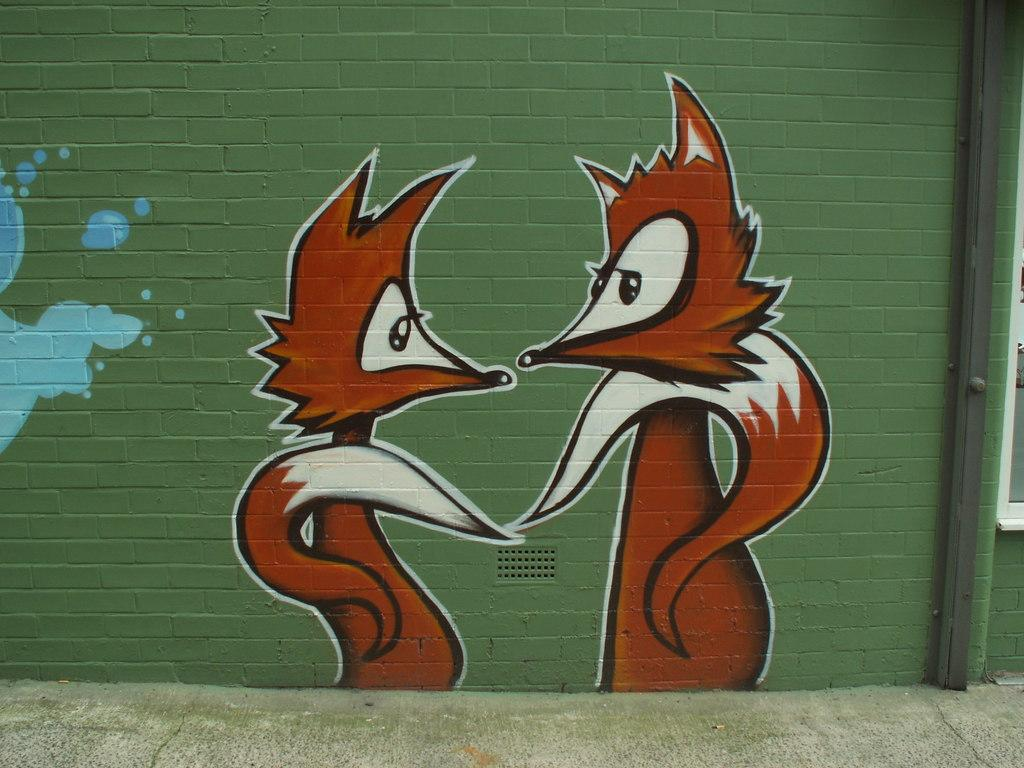What type of artwork can be seen in the image? There are wall paintings in the image. What architectural feature is present in the image? There is a window in the image. Can you determine the time of day based on the image? The image was likely taken during the day, as there is sufficient light for the wall paintings and window to be visible. What is in the middle of the wall painting? There is no specific object or feature in the middle of the wall painting; the painting is a single image or design. How does the swing appear in the image? There is no swing present in the image. 